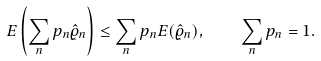<formula> <loc_0><loc_0><loc_500><loc_500>E \left ( \sum _ { n } p _ { n } \hat { \varrho } _ { n } \right ) \leq \sum _ { n } p _ { n } E ( \hat { \varrho } _ { n } ) , \quad \sum _ { n } p _ { n } = 1 .</formula> 